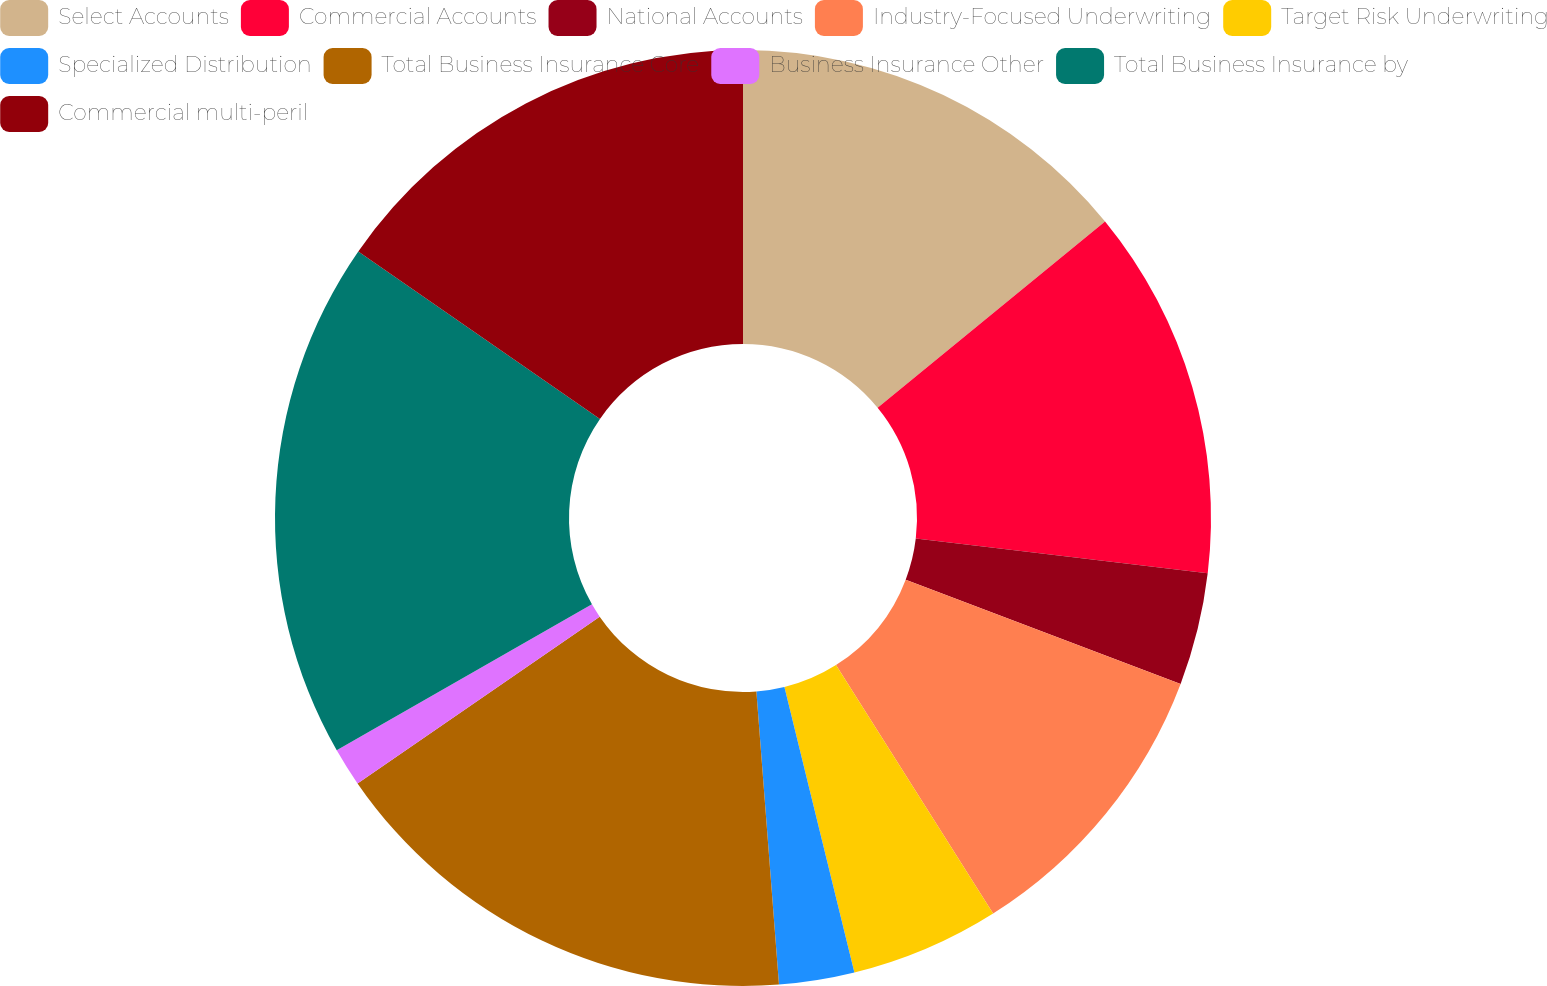<chart> <loc_0><loc_0><loc_500><loc_500><pie_chart><fcel>Select Accounts<fcel>Commercial Accounts<fcel>National Accounts<fcel>Industry-Focused Underwriting<fcel>Target Risk Underwriting<fcel>Specialized Distribution<fcel>Total Business Insurance Core<fcel>Business Insurance Other<fcel>Total Business Insurance by<fcel>Commercial multi-peril<nl><fcel>14.08%<fcel>12.81%<fcel>3.88%<fcel>10.26%<fcel>5.15%<fcel>2.6%<fcel>16.63%<fcel>1.33%<fcel>17.91%<fcel>15.36%<nl></chart> 